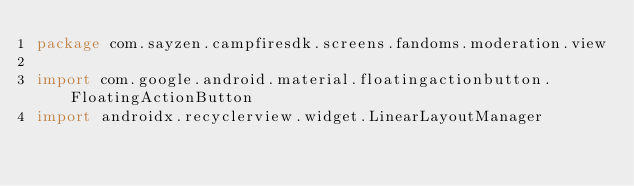<code> <loc_0><loc_0><loc_500><loc_500><_Kotlin_>package com.sayzen.campfiresdk.screens.fandoms.moderation.view

import com.google.android.material.floatingactionbutton.FloatingActionButton
import androidx.recyclerview.widget.LinearLayoutManager</code> 